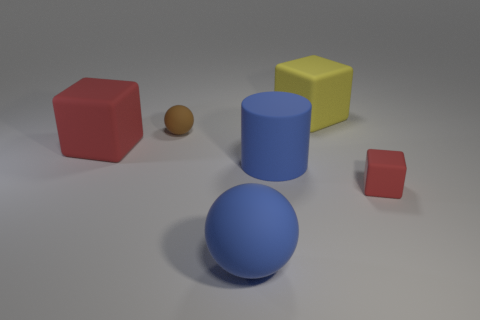Imagine we're setting up a still life for painting. How might you arrange these objects? To set up a visually interesting still life, I would suggest placing the large blue sphere in the center as a focal point due to its size and color. The red cube can be positioned to the left, slightly overlapping with the sphere to create depth. The yellow cube could be positioned to the right with the blue cylinder behind it, creating a backdrop. The tiny brown ball can be placed in the foreground to draw the viewer's eye through the entire composition, and the small red cube can be nestled off to one side to balance the arrangement. The play of lights and shadows would also add to the overall aesthetic. 